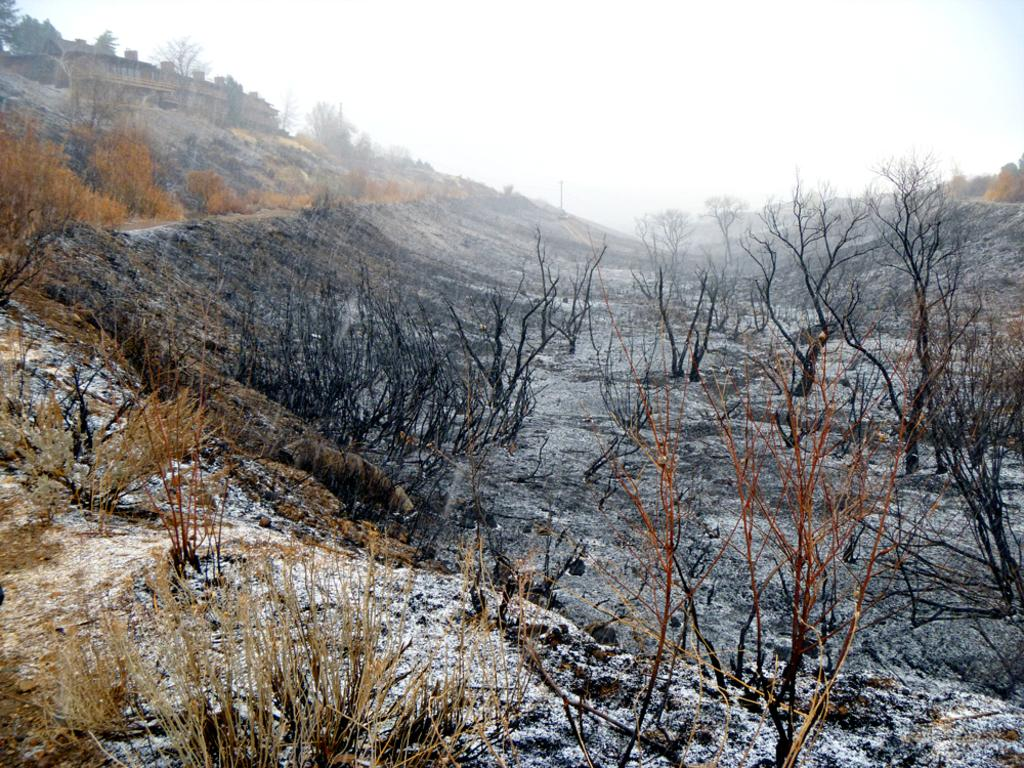What type of setting is depicted in the image? The image is an outside view. What can be seen on the ground in the image? There are many plants and trees on the ground. Where is the building located in the image? The building is on the left side of the image. What is visible at the top of the image? The sky is visible at the top of the image. How many horses are grazing on the hill in the image? There are no horses or hills present in the image; it features an outside view with plants, trees, and a building. 